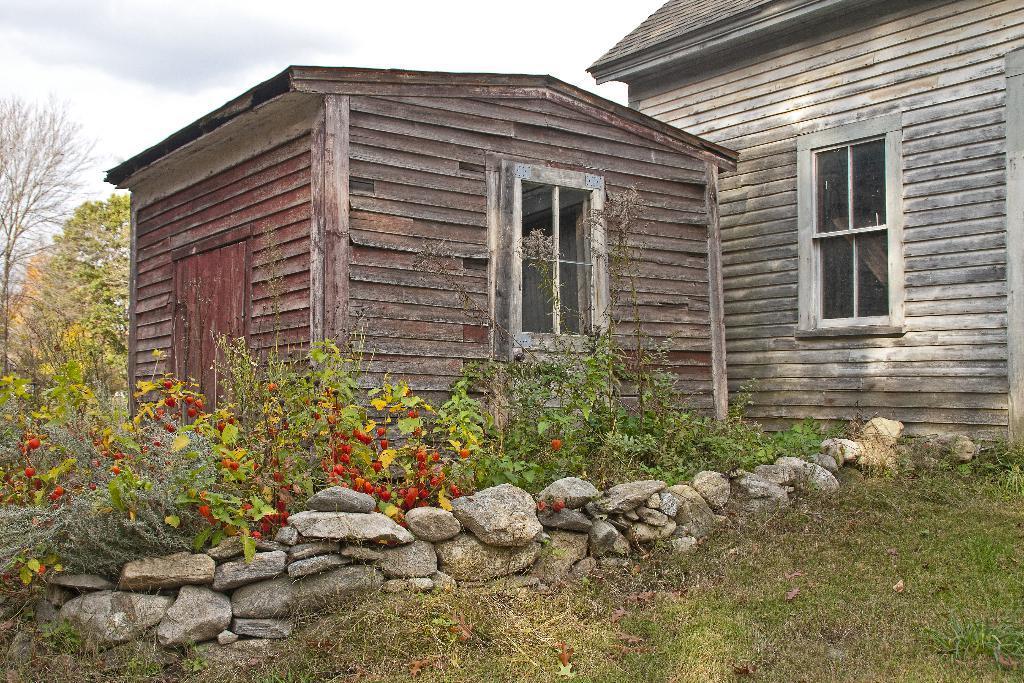Please provide a concise description of this image. In this image I see 2 houses and I see the plants, grass and the stones over here. In the background I see the trees and the sky. 